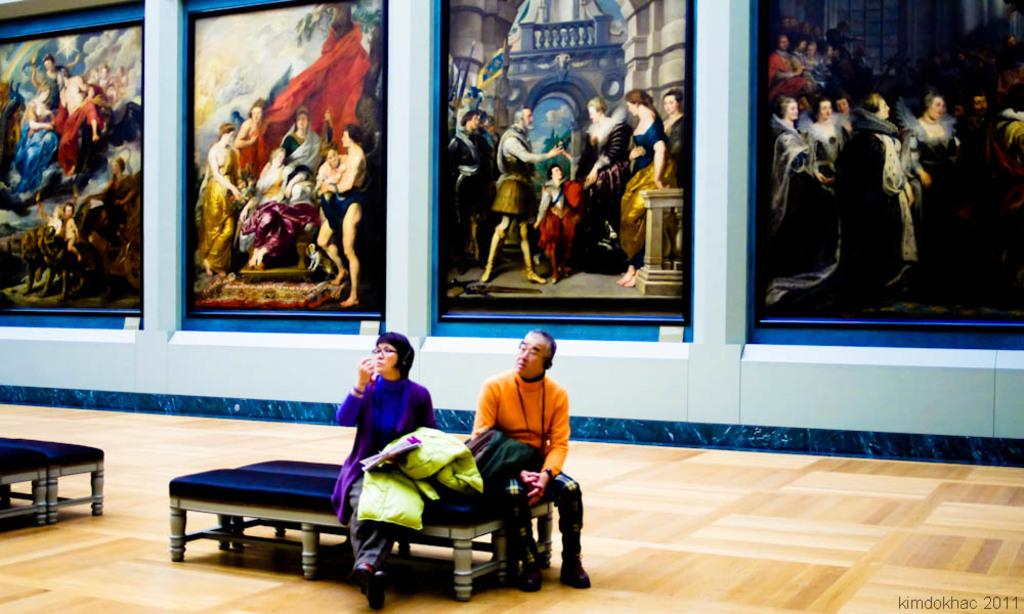Who are the people in the image? There is a woman and a man in the image. What are the woman and the man doing in the image? Both the woman and the man are sitting on a bench. What can be seen in the background of the image? There is a wall in the background of the image, with photos inscribed in it. Can you tell me how many toes the woman has in the image? There is no information about the woman's toes in the image, so it cannot be determined. 